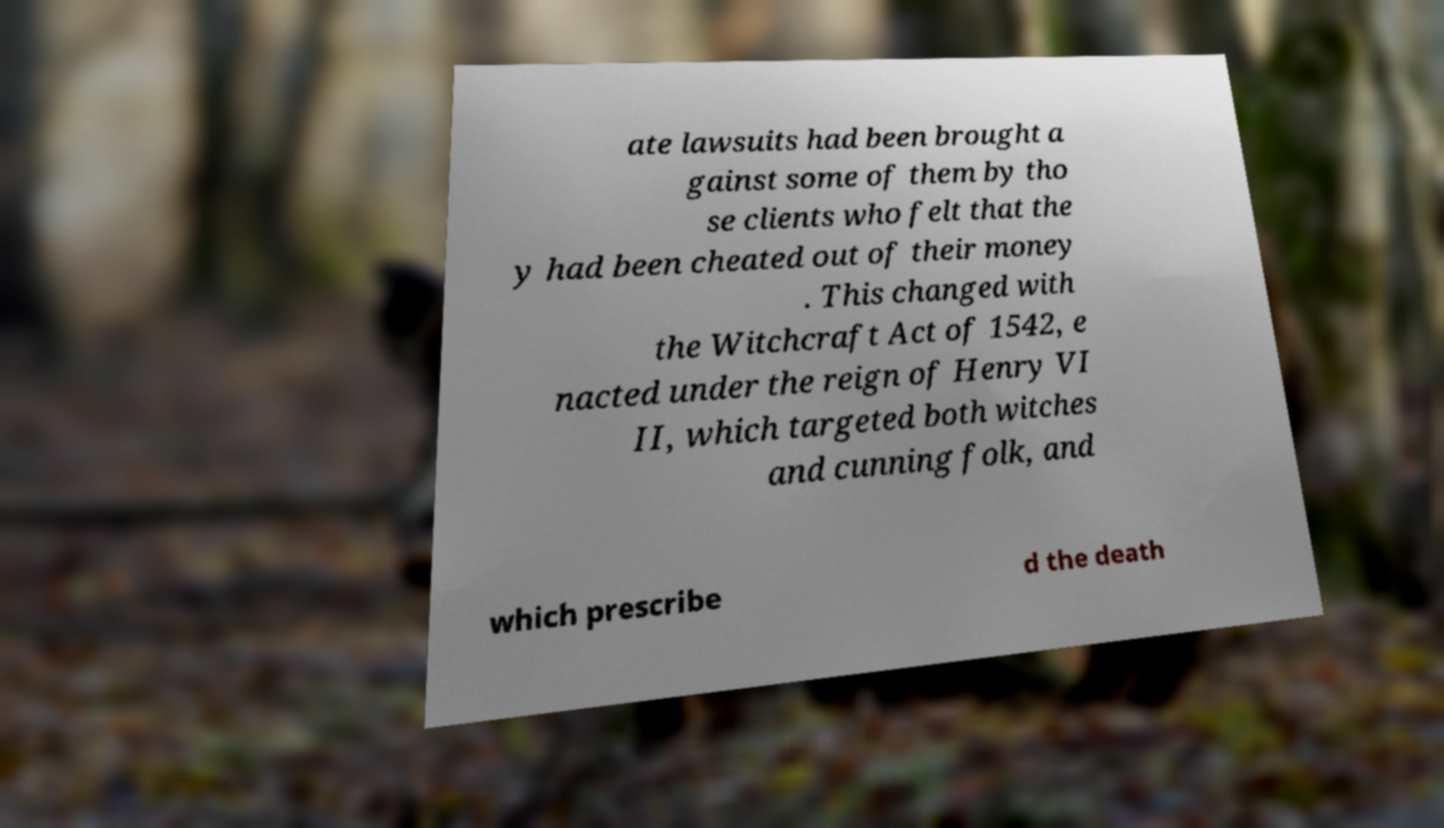Could you extract and type out the text from this image? ate lawsuits had been brought a gainst some of them by tho se clients who felt that the y had been cheated out of their money . This changed with the Witchcraft Act of 1542, e nacted under the reign of Henry VI II, which targeted both witches and cunning folk, and which prescribe d the death 